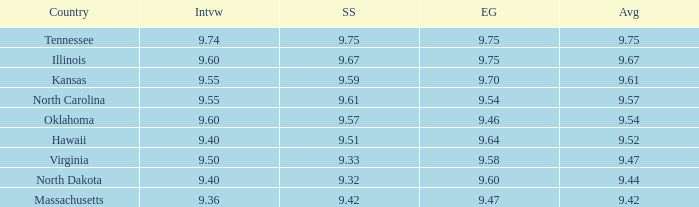Which country had the swimsuit score 9.67? Illinois. 